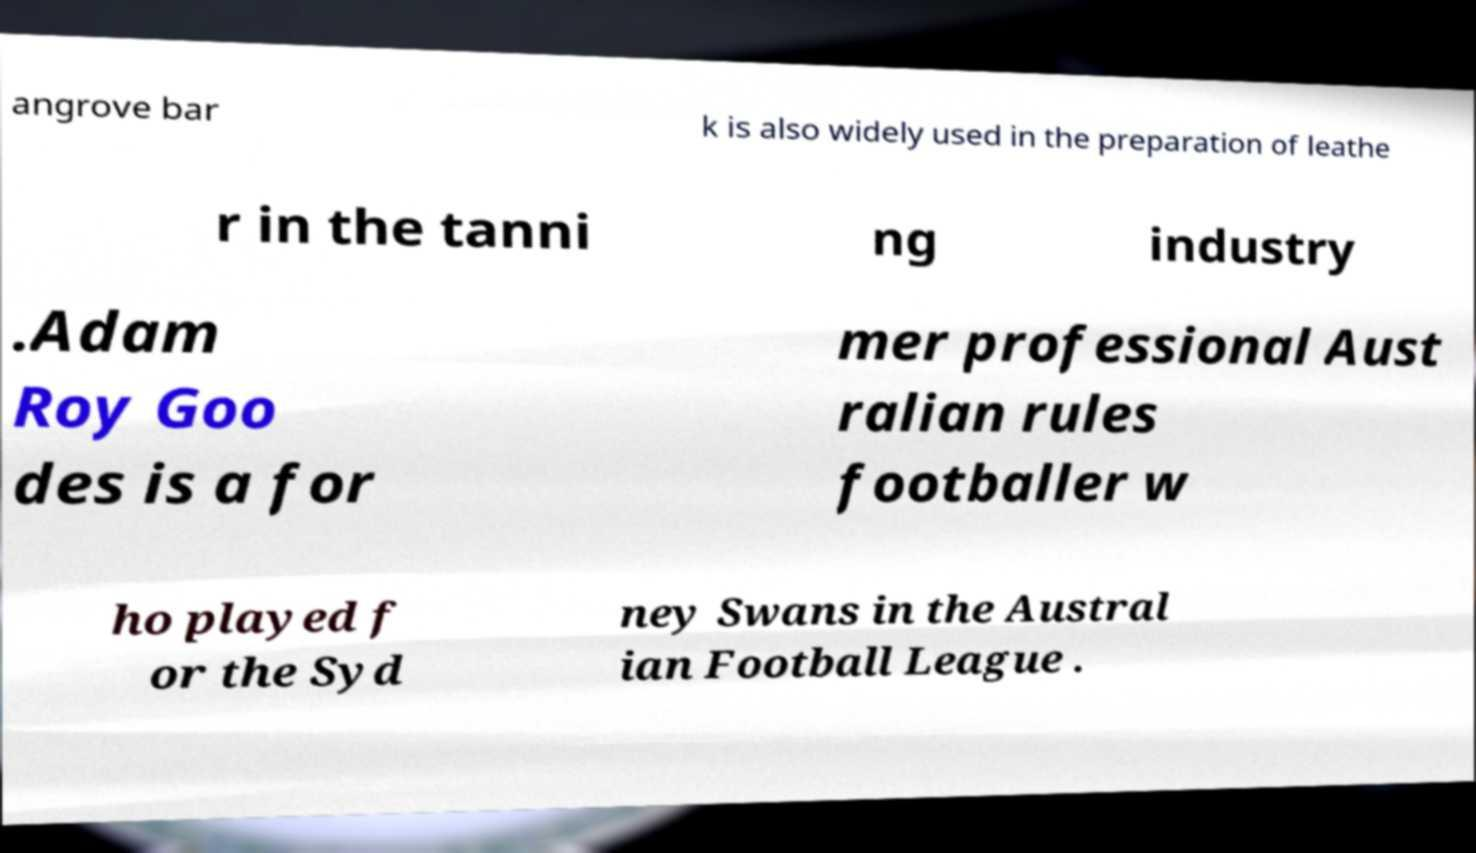Can you read and provide the text displayed in the image?This photo seems to have some interesting text. Can you extract and type it out for me? angrove bar k is also widely used in the preparation of leathe r in the tanni ng industry .Adam Roy Goo des is a for mer professional Aust ralian rules footballer w ho played f or the Syd ney Swans in the Austral ian Football League . 